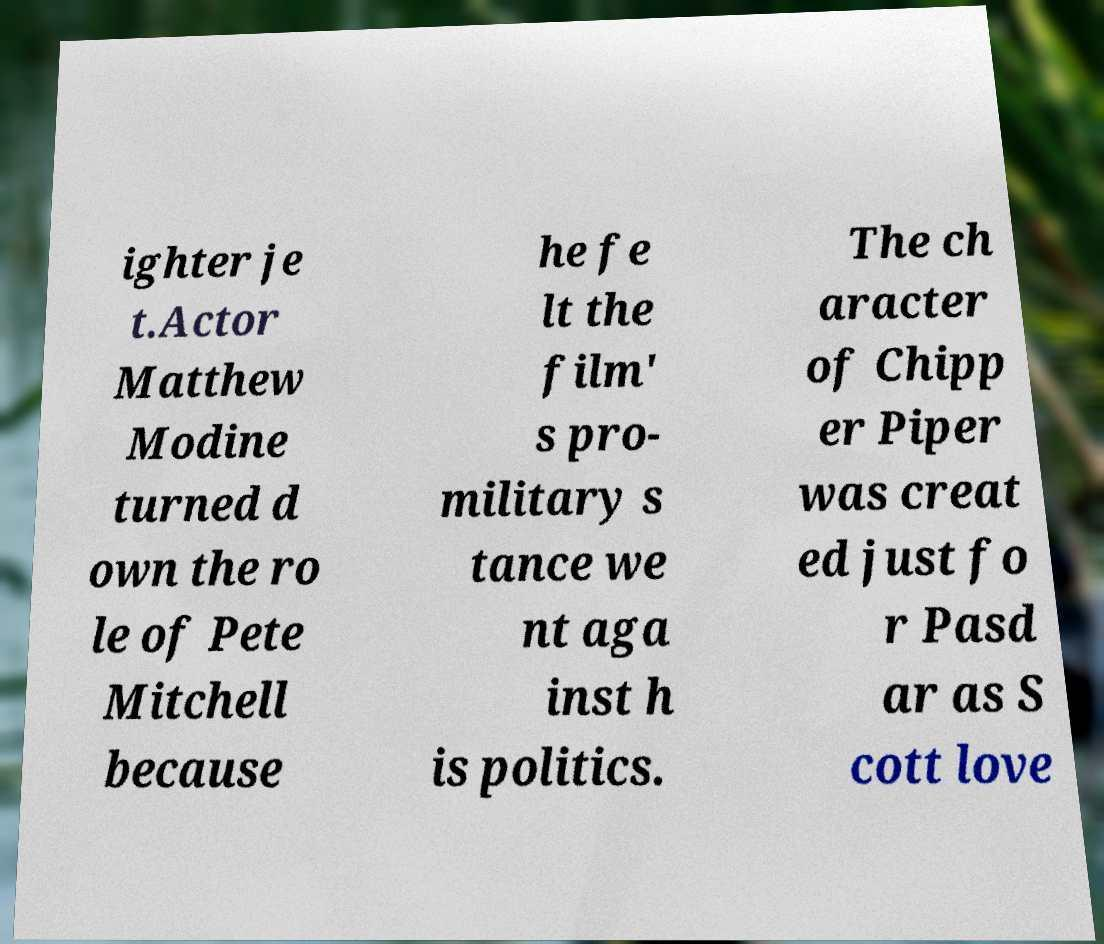Can you read and provide the text displayed in the image?This photo seems to have some interesting text. Can you extract and type it out for me? ighter je t.Actor Matthew Modine turned d own the ro le of Pete Mitchell because he fe lt the film' s pro- military s tance we nt aga inst h is politics. The ch aracter of Chipp er Piper was creat ed just fo r Pasd ar as S cott love 